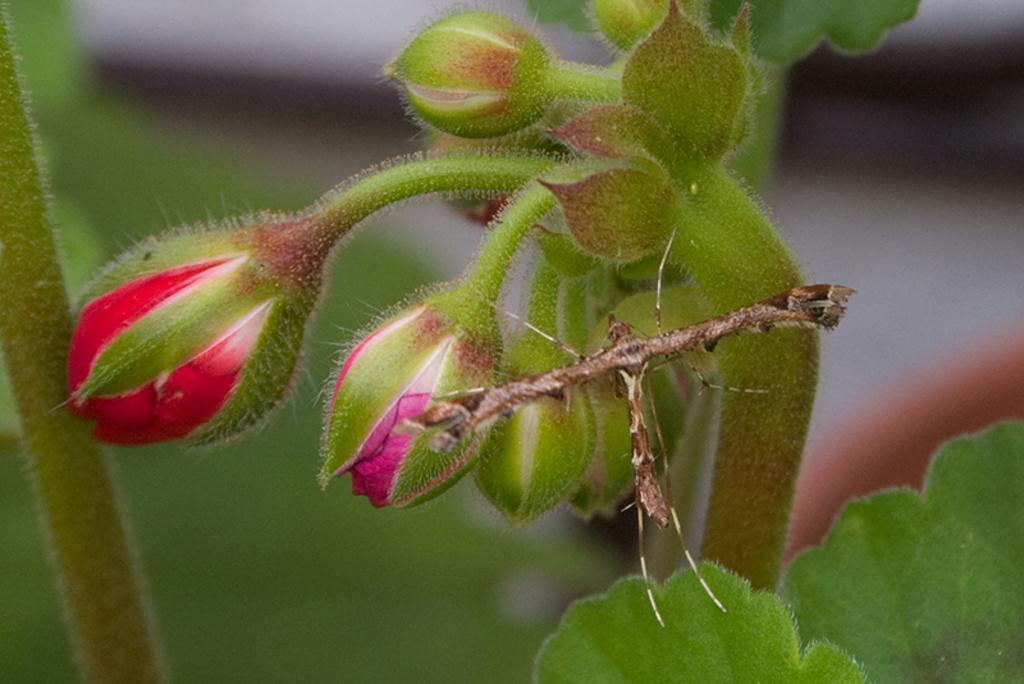What can be seen on the stems in the image? There are buds and leaves on the stems in the image. How would you describe the background of the image? The background is blurred. What colors are the buds on the stems? The buds are of red and pink color. How does the donkey participate in the competition in the image? There is no donkey or competition present in the image. 